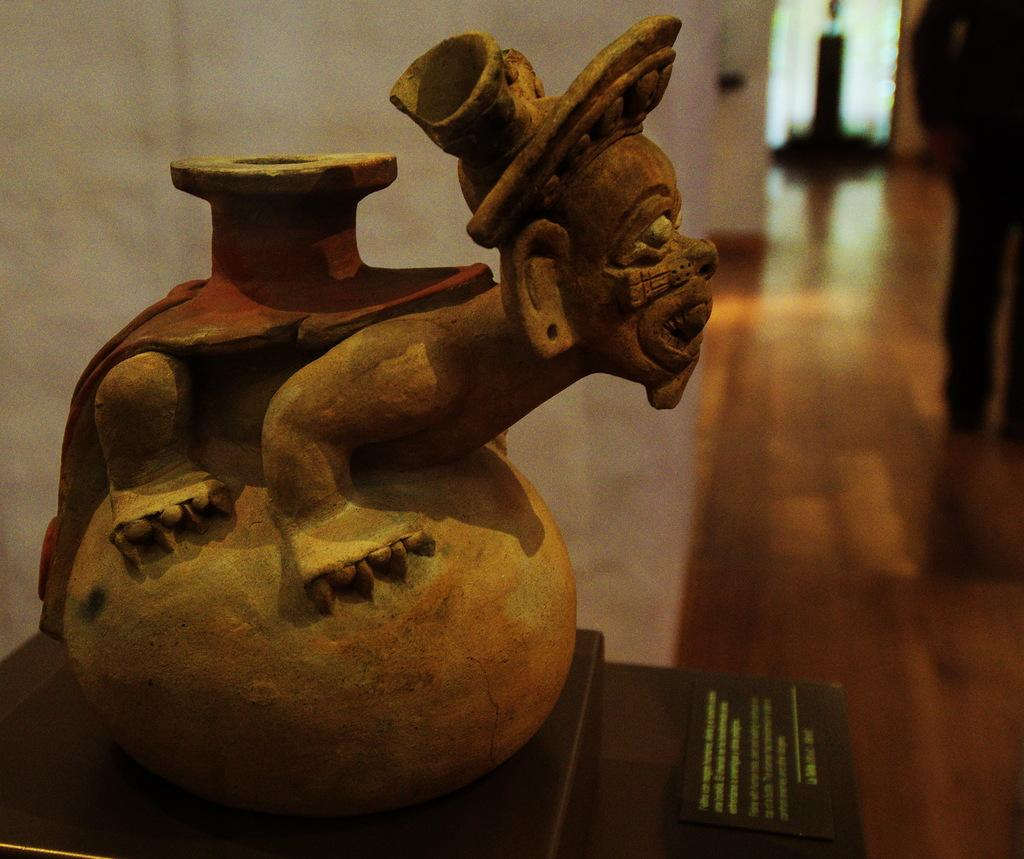What object is on the table in the image? There is a jar on a table in the image. Who or what is visible in the image? There is a person standing in the image. What type of flooring is present in the image? The person is standing on a wooden floor. Where was the image taken? The image was taken inside a room. How many pizzas are being invented in the image? There is no mention of pizzas or inventions in the image. Is there a flame visible in the image? There is no flame present in the image. 